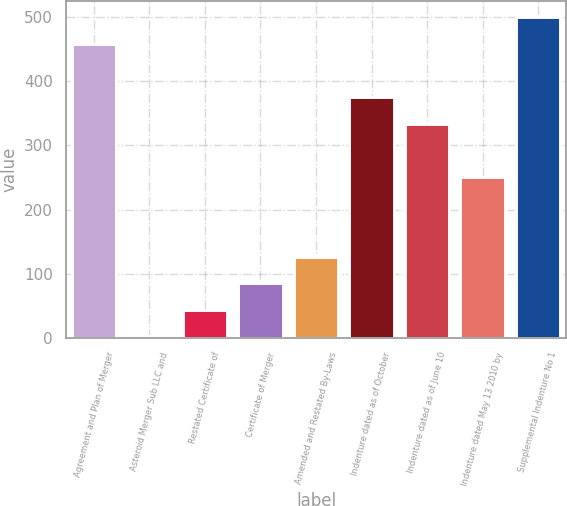<chart> <loc_0><loc_0><loc_500><loc_500><bar_chart><fcel>Agreement and Plan of Merger<fcel>Asteroid Merger Sub LLC and<fcel>Restated Certificate of<fcel>Certificate of Merger<fcel>Amended and Restated By-Laws<fcel>Indenture dated as of October<fcel>Indenture dated as of June 10<fcel>Indenture dated May 13 2010 by<fcel>Supplemental Indenture No 1<nl><fcel>458.51<fcel>2.12<fcel>43.61<fcel>85.1<fcel>126.59<fcel>375.53<fcel>334.04<fcel>251.06<fcel>500<nl></chart> 